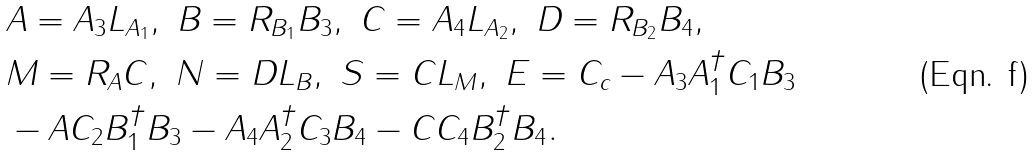<formula> <loc_0><loc_0><loc_500><loc_500>& A = A _ { 3 } L _ { A _ { 1 } } , \ B = R _ { B _ { 1 } } B _ { 3 } , \ C = A _ { 4 } L _ { A _ { 2 } } , \ D = R _ { B _ { 2 } } B _ { 4 } , \\ & M = R _ { A } C , \ N = D L _ { B } , \ S = C L _ { M } , \ E = C _ { c } - A _ { 3 } A _ { 1 } ^ { \dagger } C _ { 1 } B _ { 3 } \\ & - A C _ { 2 } B _ { 1 } ^ { \dagger } B _ { 3 } - A _ { 4 } A _ { 2 } ^ { \dagger } C _ { 3 } B _ { 4 } - C C _ { 4 } B _ { 2 } ^ { \dagger } B _ { 4 } .</formula> 